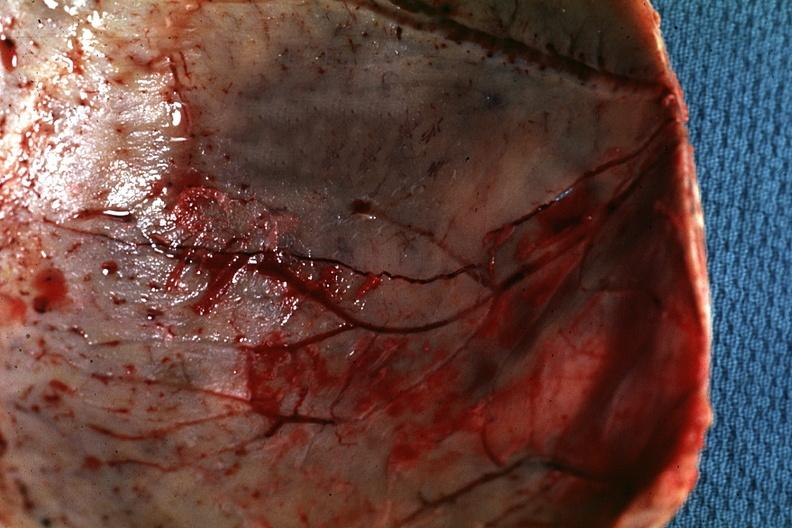what shown very thin skull eggshell type?
Answer the question using a single word or phrase. Fracture line 